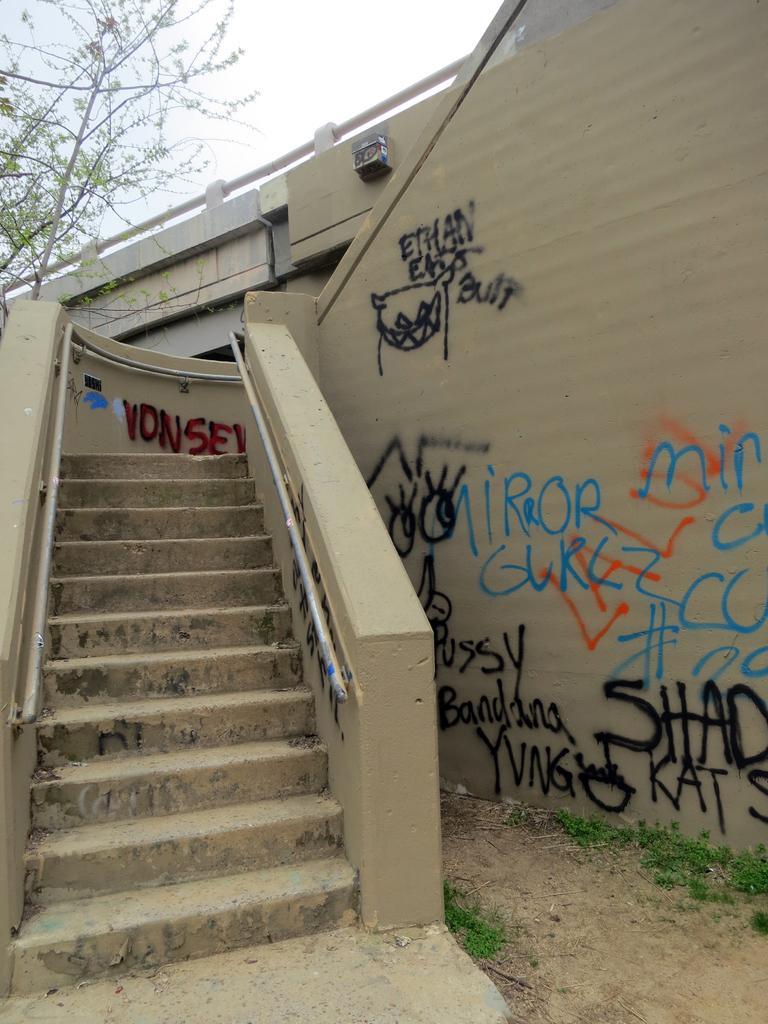Please provide a concise description of this image. In this picture we can see steps, grass, wall with paintings, trees and in the background we can see the sky. 